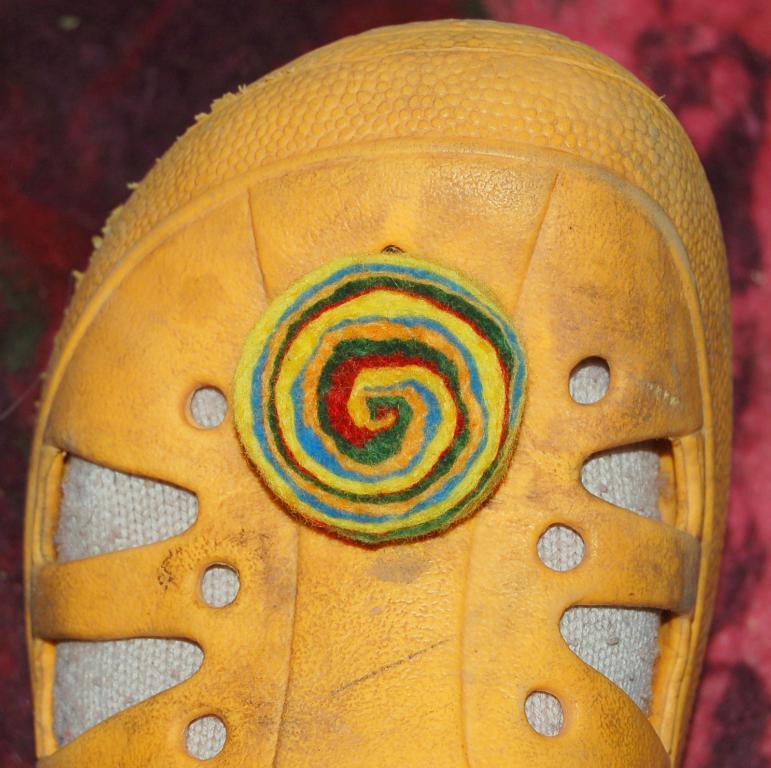Please provide a concise description of this image. In the center of the image we can see a footwear which is in yellow color. 